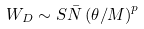<formula> <loc_0><loc_0><loc_500><loc_500>W _ { D } \sim S \bar { N } \left ( { \theta / M } \right ) ^ { p }</formula> 